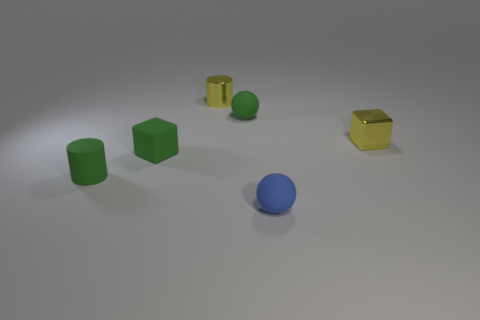Does the rubber block have the same color as the rubber cylinder?
Make the answer very short. Yes. There is a tiny cube that is the same color as the rubber cylinder; what is its material?
Your answer should be very brief. Rubber. How many things are either tiny green cylinders or small yellow metal things to the right of the metal cylinder?
Your response must be concise. 2. How many other things are the same size as the yellow metal cylinder?
Your answer should be compact. 5. Are there more tiny green rubber balls to the left of the yellow shiny cube than large matte cubes?
Offer a terse response. Yes. Is there any other thing that has the same color as the tiny rubber cylinder?
Make the answer very short. Yes. There is a yellow thing that is made of the same material as the yellow block; what is its shape?
Your answer should be very brief. Cylinder. Do the tiny ball that is behind the tiny green cylinder and the tiny yellow cylinder have the same material?
Offer a terse response. No. What shape is the object that is the same color as the metal cube?
Make the answer very short. Cylinder. Is the color of the small matte sphere behind the tiny yellow metallic block the same as the tiny cylinder on the left side of the metallic cylinder?
Your response must be concise. Yes. 